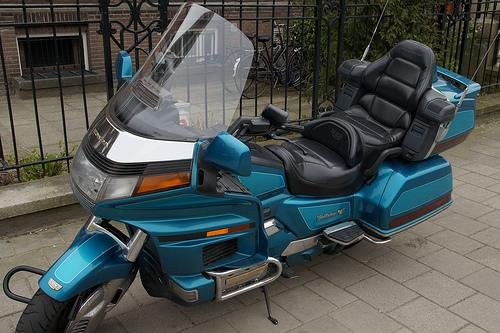Question: what color are the seats on the bikes behind the fence?
Choices:
A. White.
B. Tan.
C. Black.
D. Red.
Answer with the letter. Answer: C Question: what type of vehicle is behind the fence?
Choices:
A. Bike.
B. Scooter.
C. Automobile.
D. Motorcycle.
Answer with the letter. Answer: A Question: what is the color of the seat on the motorcycle?
Choices:
A. Blue.
B. Black.
C. White.
D. Red.
Answer with the letter. Answer: B Question: what color are the tiles on the ground?
Choices:
A. Black.
B. Gray.
C. White.
D. Blue.
Answer with the letter. Answer: B Question: how many vehicles are visible?
Choices:
A. Three.
B. Two.
C. One.
D. Four.
Answer with the letter. Answer: A 